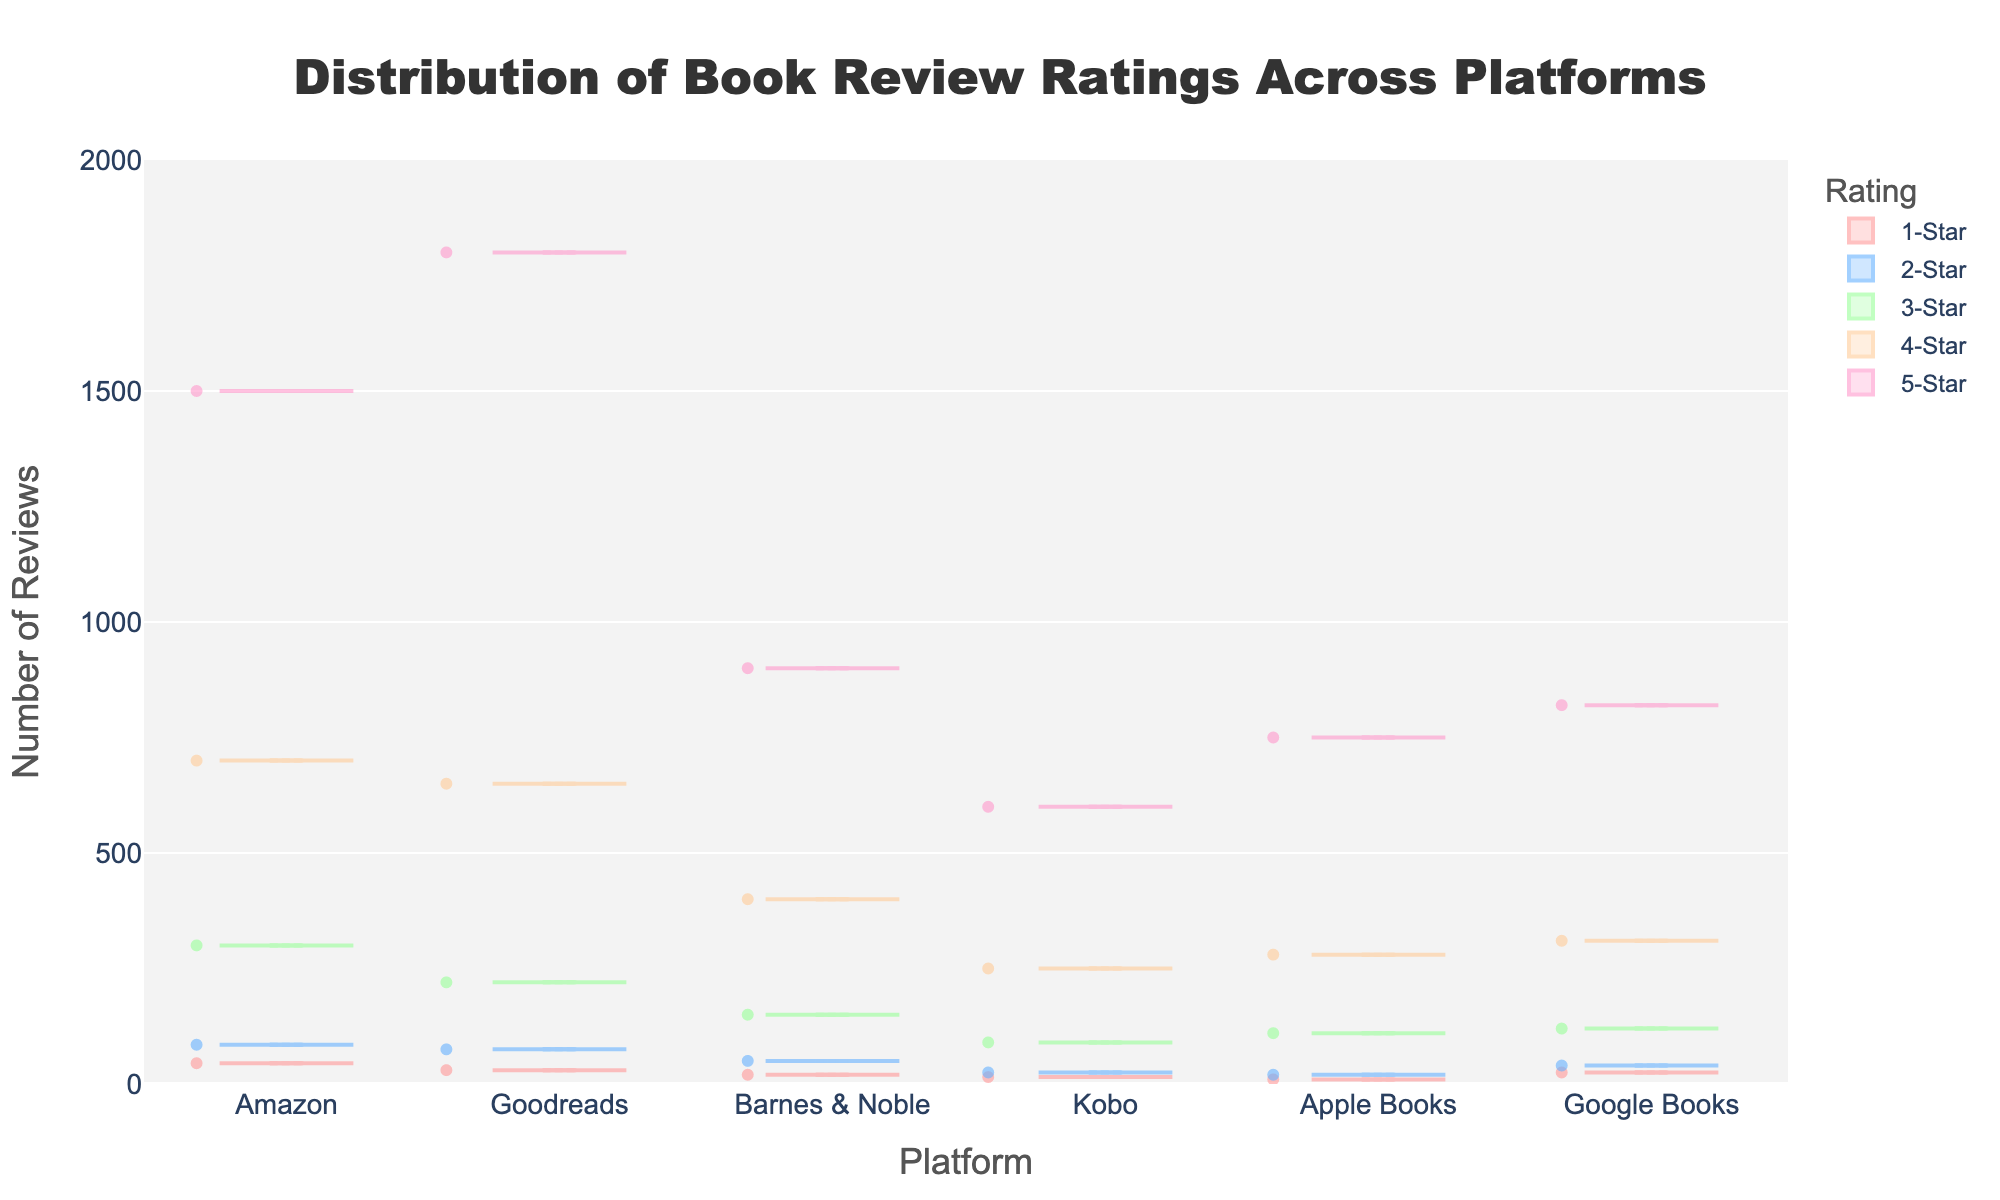What is the highest number of 5-Star reviews across all platforms? To find the highest number of 5-Star reviews, look at the values for "5-Star" across all platforms. Amazon has the most with 1500.
Answer: 1500 Which platform has the fewest 1-Star reviews? To determine this, compare the number of 1-Star reviews across all platforms. Apple Books has the fewest with 10 reviews.
Answer: Apple Books How many platforms have more than 300 4-Star reviews? To find this, check the number of platforms where the 4-Star review count exceeds 300. Amazon, Goodreads, and Google Books have more than 300 4-Star reviews. So, there are three platforms in total.
Answer: 3 What's the total number of reviews for Kobo? To get the total, sum up the reviews for all star ratings on Kobo. The numbers are 15 + 25 + 90 + 250 + 600 = 980.
Answer: 980 Which platform has the most balanced distribution of reviews across star ratings? To answer this, look at the figure and check each platform's star rating distributions. Kobo and Apple Books seem to have fewer extreme differences compared to others.
Answer: Kobo and Apple Books What is the difference in the number of 3-Star reviews between Goodreads and Barnes & Noble? To find out, subtract the number of 3-Star reviews in Barnes & Noble from Goodreads. This results in 220 (Goodreads) - 150 (Barnes & Noble) = 70.
Answer: 70 Which two platforms have the closest number of 2-Star reviews, and what is the number? Look for the platforms with similar 2-Star review counts. Kobo and Google Books are closest with 25 and 40 reviews, respectively.
Answer: Kobo and Google Books, 25 and 40 respectively How many more 5-Star reviews does Amazon have compared to Kobo? To determine this, subtract the number of 5-Star reviews for Kobo from Amazon. The result is 1500 (Amazon) - 600 (Kobo) = 900.
Answer: 900 What's the average number of 3-Star reviews across all platforms? First, sum the 3-Star reviews for all the platforms: 300 (Amazon) + 220 (Goodreads) + 150 (Barnes & Noble) + 90 (Kobo) + 110 (Apple Books) + 120 (Google Books) = 990. Then, divide by the number of platforms, which is 6. So, 990 / 6 = 165.
Answer: 165 Which platform has the highest variance in the number of reviews across all star ratings? Variance measures the dispersion between numbers. Amazon has the most varied distribution with a wide range from 45 to 1500 reviews.
Answer: Amazon 